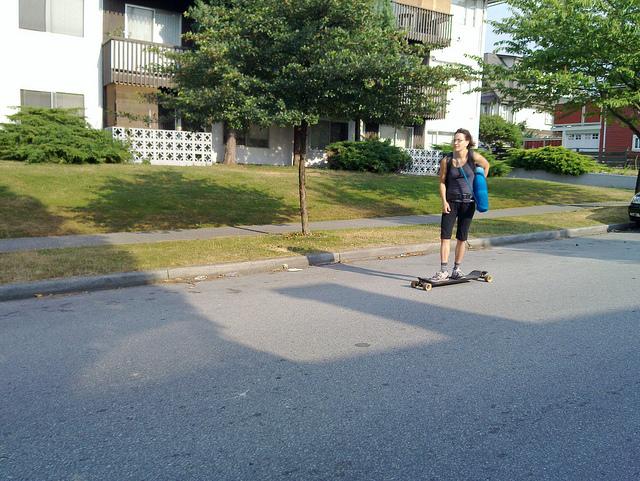What is the person riding?
Give a very brief answer. Skateboard. What is the girl kicking around?
Keep it brief. Skateboard. What is the gender of most of these people?
Be succinct. Female. What is the sidewalk made of?
Quick response, please. Cement. Where is this person going to/coming from?
Quick response, please. House. What is in the picture?
Keep it brief. Woman skateboarding. What is the building made of?
Write a very short answer. Wood. Are the curbs painted yellow?
Concise answer only. No. Would it be easy to cut the grass on this lawn?
Short answer required. Yes. 